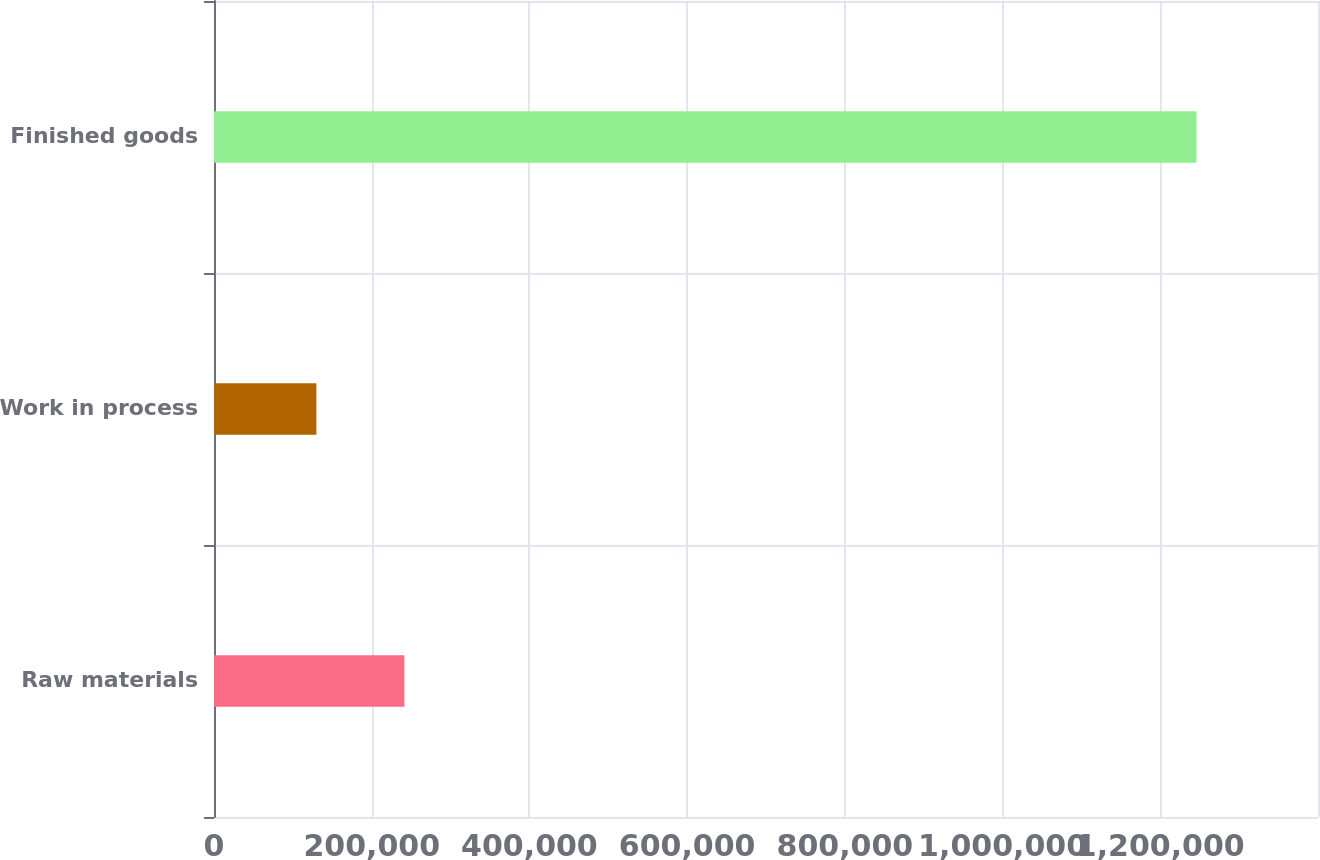Convert chart. <chart><loc_0><loc_0><loc_500><loc_500><bar_chart><fcel>Raw materials<fcel>Work in process<fcel>Finished goods<nl><fcel>241439<fcel>129827<fcel>1.24595e+06<nl></chart> 